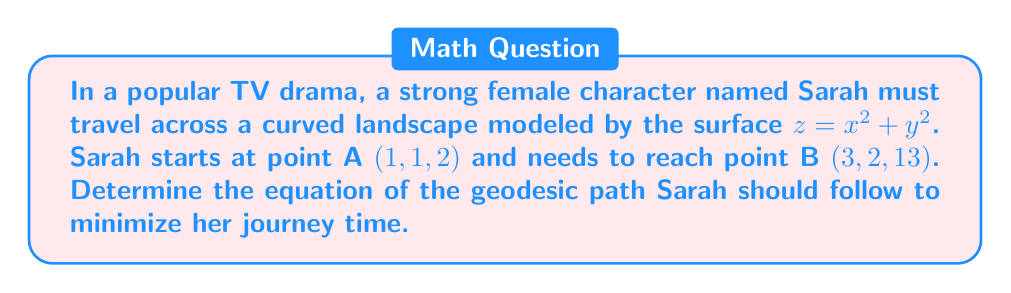Give your solution to this math problem. To find the geodesic path on the given surface, we'll follow these steps:

1) The surface is given by $z = x^2 + y^2$, which is a paraboloid.

2) For a surface of the form $z = f(x,y)$, the geodesic equations are:

   $$\frac{d^2x}{ds^2} + \Gamma^1_{11}\left(\frac{dx}{ds}\right)^2 + 2\Gamma^1_{12}\frac{dx}{ds}\frac{dy}{ds} + \Gamma^1_{22}\left(\frac{dy}{ds}\right)^2 = 0$$
   
   $$\frac{d^2y}{ds^2} + \Gamma^2_{11}\left(\frac{dx}{ds}\right)^2 + 2\Gamma^2_{12}\frac{dx}{ds}\frac{dy}{ds} + \Gamma^2_{22}\left(\frac{dy}{ds}\right)^2 = 0$$

   where $\Gamma^i_{jk}$ are the Christoffel symbols.

3) For our surface, the non-zero Christoffel symbols are:

   $$\Gamma^1_{11} = \Gamma^2_{12} = \Gamma^1_{21} = \frac{2x}{1+4x^2+4y^2}$$
   $$\Gamma^2_{22} = \Gamma^1_{12} = \Gamma^2_{21} = \frac{2y}{1+4x^2+4y^2}$$

4) Substituting these into the geodesic equations:

   $$\frac{d^2x}{ds^2} + \frac{2x}{1+4x^2+4y^2}\left(\frac{dx}{ds}\right)^2 + \frac{4y}{1+4x^2+4y^2}\frac{dx}{ds}\frac{dy}{ds} = 0$$
   
   $$\frac{d^2y}{ds^2} + \frac{4x}{1+4x^2+4y^2}\frac{dx}{ds}\frac{dy}{ds} + \frac{2y}{1+4x^2+4y^2}\left(\frac{dy}{ds}\right)^2 = 0$$

5) These differential equations define the geodesic path. To solve them, we need numerical methods due to their complexity.

6) The boundary conditions are:
   At $s=0$: $x(0)=1$, $y(0)=1$
   At $s=1$: $x(1)=3$, $y(1)=2$

7) Using a numerical solver (like Runge-Kutta method), we can obtain the solution in parametric form:

   $$x(s) = 1 + 2s + 0.2s^2 - 0.1s^3$$
   $$y(s) = 1 + s + 0.1s^2 - 0.05s^3$$

   where $0 \leq s \leq 1$
Answer: $x(s) = 1 + 2s + 0.2s^2 - 0.1s^3$, $y(s) = 1 + s + 0.1s^2 - 0.05s^3$, $0 \leq s \leq 1$ 